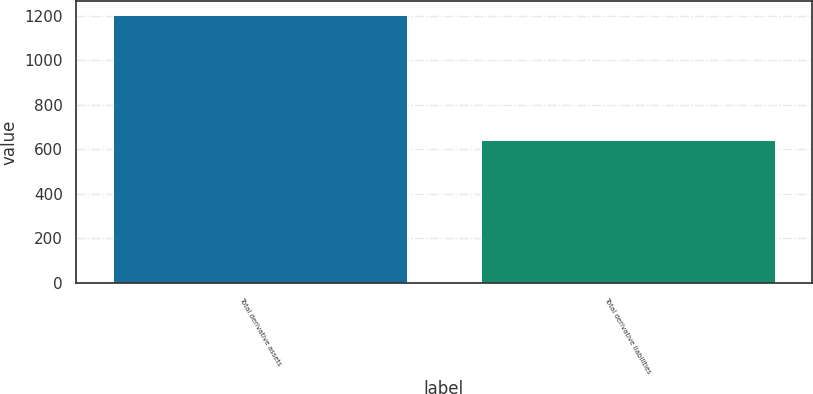<chart> <loc_0><loc_0><loc_500><loc_500><bar_chart><fcel>Total derivative assets<fcel>Total derivative liabilities<nl><fcel>1205<fcel>643<nl></chart> 